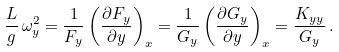<formula> <loc_0><loc_0><loc_500><loc_500>\frac { L } { g } \, \omega _ { y } ^ { 2 } = \frac { 1 } { F _ { y } } \left ( \frac { \partial F _ { y } } { \partial y } \right ) _ { x } = \frac { 1 } { G _ { y } } \left ( \frac { \partial G _ { y } } { \partial y } \right ) _ { x } = \frac { K _ { y y } } { G _ { y } } \, .</formula> 